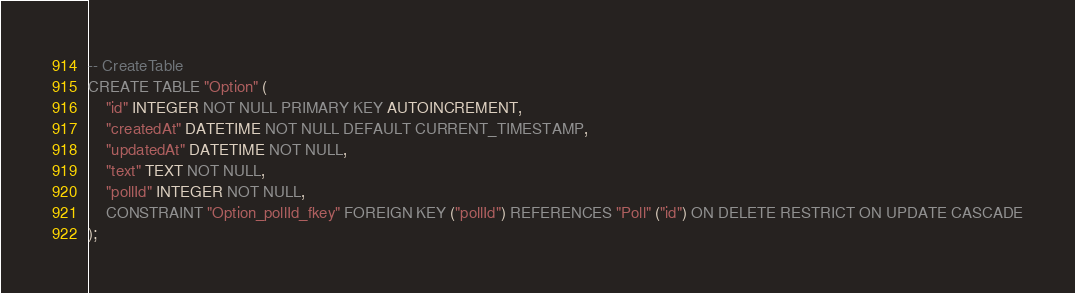Convert code to text. <code><loc_0><loc_0><loc_500><loc_500><_SQL_>-- CreateTable
CREATE TABLE "Option" (
    "id" INTEGER NOT NULL PRIMARY KEY AUTOINCREMENT,
    "createdAt" DATETIME NOT NULL DEFAULT CURRENT_TIMESTAMP,
    "updatedAt" DATETIME NOT NULL,
    "text" TEXT NOT NULL,
    "pollId" INTEGER NOT NULL,
    CONSTRAINT "Option_pollId_fkey" FOREIGN KEY ("pollId") REFERENCES "Poll" ("id") ON DELETE RESTRICT ON UPDATE CASCADE
);
</code> 